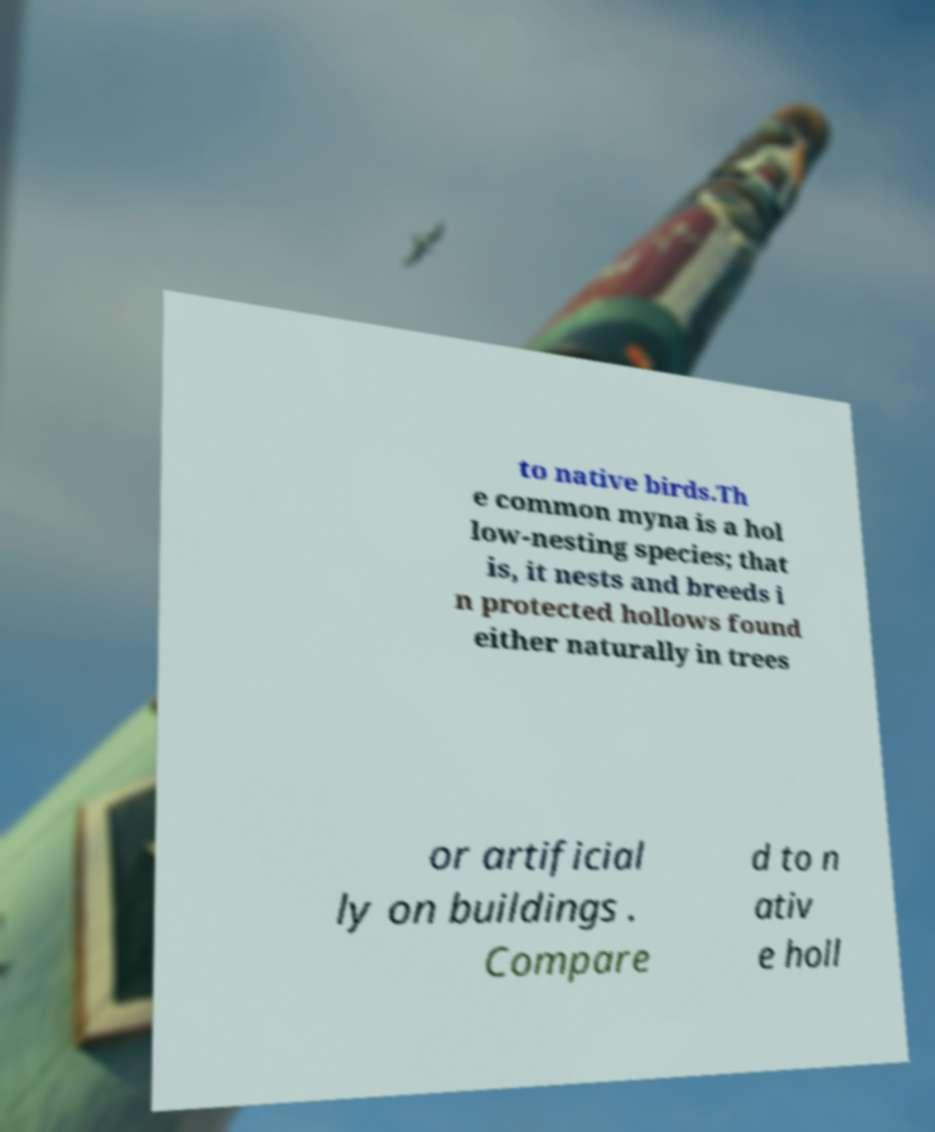Please read and relay the text visible in this image. What does it say? to native birds.Th e common myna is a hol low-nesting species; that is, it nests and breeds i n protected hollows found either naturally in trees or artificial ly on buildings . Compare d to n ativ e holl 